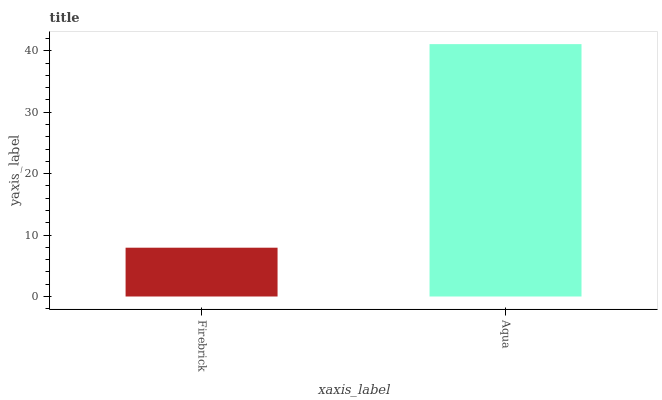Is Firebrick the minimum?
Answer yes or no. Yes. Is Aqua the maximum?
Answer yes or no. Yes. Is Aqua the minimum?
Answer yes or no. No. Is Aqua greater than Firebrick?
Answer yes or no. Yes. Is Firebrick less than Aqua?
Answer yes or no. Yes. Is Firebrick greater than Aqua?
Answer yes or no. No. Is Aqua less than Firebrick?
Answer yes or no. No. Is Aqua the high median?
Answer yes or no. Yes. Is Firebrick the low median?
Answer yes or no. Yes. Is Firebrick the high median?
Answer yes or no. No. Is Aqua the low median?
Answer yes or no. No. 